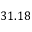Convert formula to latex. <formula><loc_0><loc_0><loc_500><loc_500>3 1 . 1 8</formula> 